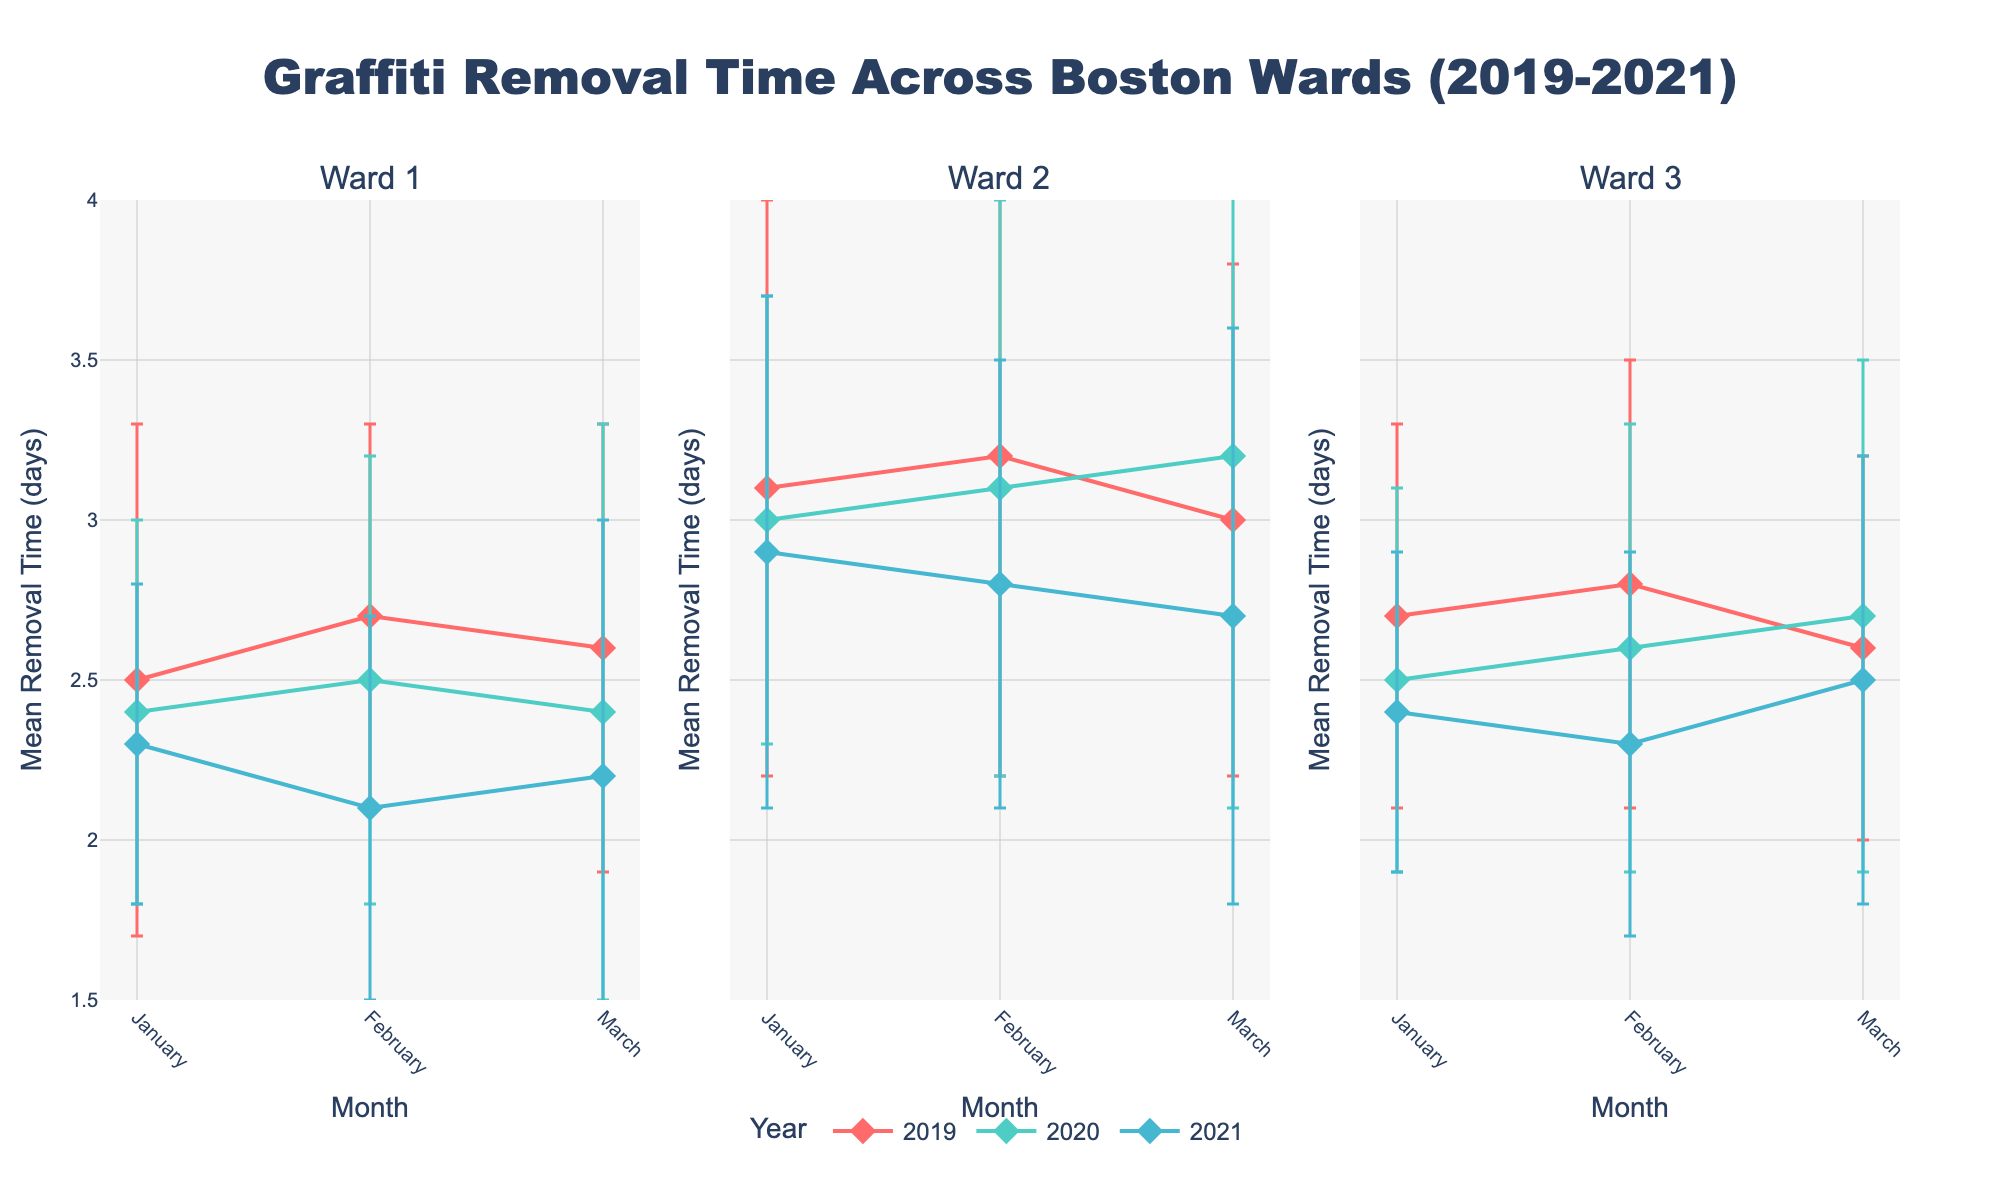What's the title of the figure? The title of the figure is written at the top center and should describe the content of the plot.
Answer: Graffiti Removal Time Across Boston Wards (2019-2021) What is the range of the y-axis for Mean Removal Time? The y-axis range is displayed along the vertical axis and showcases the minimum and maximum values.
Answer: 1.5 to 4 days How many subplots are in the figure? The number of subplots can be determined by counting the separate plots within the main figure.
Answer: 3 Which ward had the highest mean removal time in January 2019? By comparing the y-values for January 2019 across all wards, you can identify the highest point.
Answer: Ward 2 Which year had the lowest mean removal time in Ward 3 during March? By observing the markers for March in Ward 3's subplot and comparing the y-values, you can determine the year with the lowest removal time.
Answer: 2021 In Ward 1, how did the mean removal time in February change from 2019 to 2021? To answer this, compare the y-values for February in 2019, 2020, and 2021 within Ward 1's subplot. First identify the mean removal times (2.7, 2.5, 2.1 respectively) and then calculate the change: from 2.7 (2019) to 2.1 (2021), the change is 2.1 - 2.7 = -0.6 days.
Answer: Decreased by 0.6 days Which ward had the most significant decrease in mean removal time from 2019 to 2021 for March? For each subplot, note the y-values for March in 2019 and 2021, then calculate the difference: Ward 1 (2.6 to 2.2, decrease of 0.4), Ward 2 (3.0 to 2.7, decrease of 0.3), Ward 3 (2.6 to 2.5, decrease of 0.1). The ward with the largest difference indicates the most significant decrease.
Answer: Ward 1 What is the general trend of graffiti removal time across the years in Ward 2? By examining the subplots and trend lines for each year in Ward 2's subplot, one can observe patterns or general directions of the data. In Ward 2, the removal time is consistently decreasing from 2019 (average above 3 days) to 2021 (average below 3 days).
Answer: Decreasing Compare the mean removal times (with error bars) between January and March of 2020 in Ward 3. Look at the January and March data points for Ward 3 in 2020, then observe the difference in y-values along with the length of the error bars. January: 2.5 ± 0.6, March: 2.7 ± 0.8.
Answer: January is slightly lower with less variability 